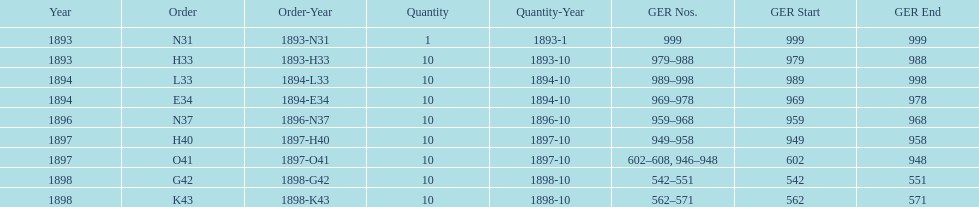What is the aggregate amount of locomotives manufactured during this time? 81. 